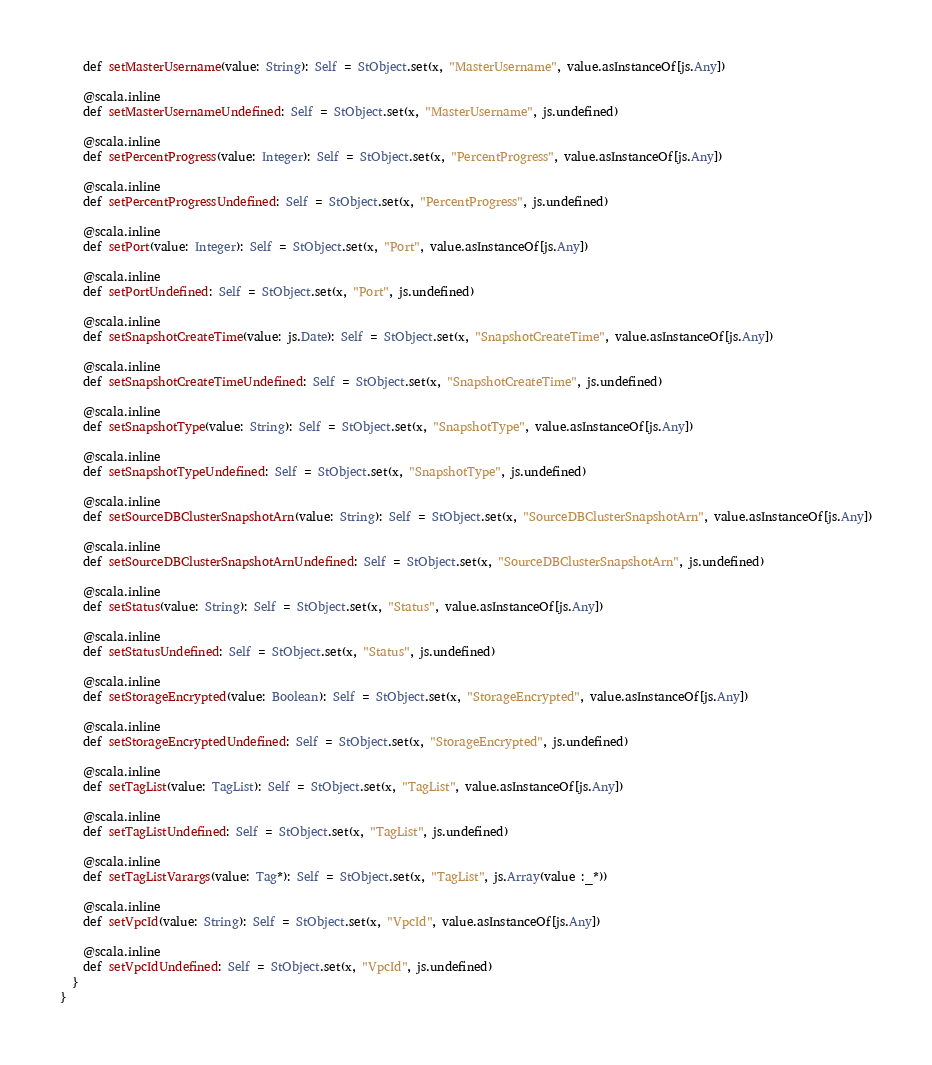<code> <loc_0><loc_0><loc_500><loc_500><_Scala_>    def setMasterUsername(value: String): Self = StObject.set(x, "MasterUsername", value.asInstanceOf[js.Any])
    
    @scala.inline
    def setMasterUsernameUndefined: Self = StObject.set(x, "MasterUsername", js.undefined)
    
    @scala.inline
    def setPercentProgress(value: Integer): Self = StObject.set(x, "PercentProgress", value.asInstanceOf[js.Any])
    
    @scala.inline
    def setPercentProgressUndefined: Self = StObject.set(x, "PercentProgress", js.undefined)
    
    @scala.inline
    def setPort(value: Integer): Self = StObject.set(x, "Port", value.asInstanceOf[js.Any])
    
    @scala.inline
    def setPortUndefined: Self = StObject.set(x, "Port", js.undefined)
    
    @scala.inline
    def setSnapshotCreateTime(value: js.Date): Self = StObject.set(x, "SnapshotCreateTime", value.asInstanceOf[js.Any])
    
    @scala.inline
    def setSnapshotCreateTimeUndefined: Self = StObject.set(x, "SnapshotCreateTime", js.undefined)
    
    @scala.inline
    def setSnapshotType(value: String): Self = StObject.set(x, "SnapshotType", value.asInstanceOf[js.Any])
    
    @scala.inline
    def setSnapshotTypeUndefined: Self = StObject.set(x, "SnapshotType", js.undefined)
    
    @scala.inline
    def setSourceDBClusterSnapshotArn(value: String): Self = StObject.set(x, "SourceDBClusterSnapshotArn", value.asInstanceOf[js.Any])
    
    @scala.inline
    def setSourceDBClusterSnapshotArnUndefined: Self = StObject.set(x, "SourceDBClusterSnapshotArn", js.undefined)
    
    @scala.inline
    def setStatus(value: String): Self = StObject.set(x, "Status", value.asInstanceOf[js.Any])
    
    @scala.inline
    def setStatusUndefined: Self = StObject.set(x, "Status", js.undefined)
    
    @scala.inline
    def setStorageEncrypted(value: Boolean): Self = StObject.set(x, "StorageEncrypted", value.asInstanceOf[js.Any])
    
    @scala.inline
    def setStorageEncryptedUndefined: Self = StObject.set(x, "StorageEncrypted", js.undefined)
    
    @scala.inline
    def setTagList(value: TagList): Self = StObject.set(x, "TagList", value.asInstanceOf[js.Any])
    
    @scala.inline
    def setTagListUndefined: Self = StObject.set(x, "TagList", js.undefined)
    
    @scala.inline
    def setTagListVarargs(value: Tag*): Self = StObject.set(x, "TagList", js.Array(value :_*))
    
    @scala.inline
    def setVpcId(value: String): Self = StObject.set(x, "VpcId", value.asInstanceOf[js.Any])
    
    @scala.inline
    def setVpcIdUndefined: Self = StObject.set(x, "VpcId", js.undefined)
  }
}
</code> 